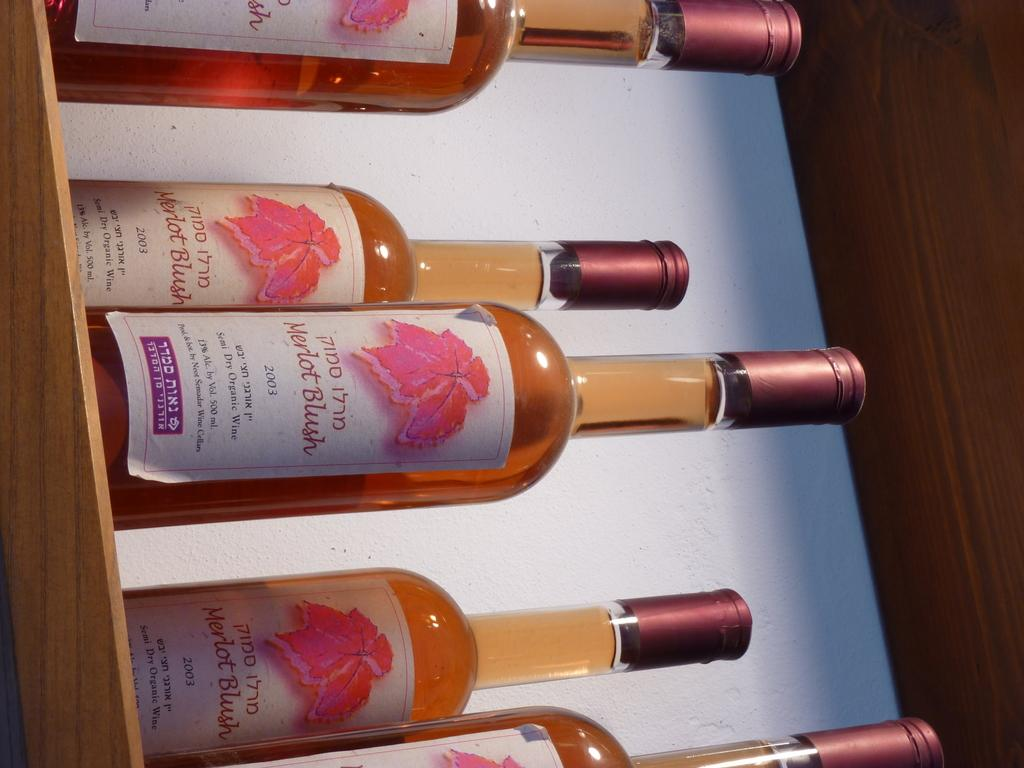<image>
Describe the image concisely. Several bottles of Merlot organic wine dated 2003. 